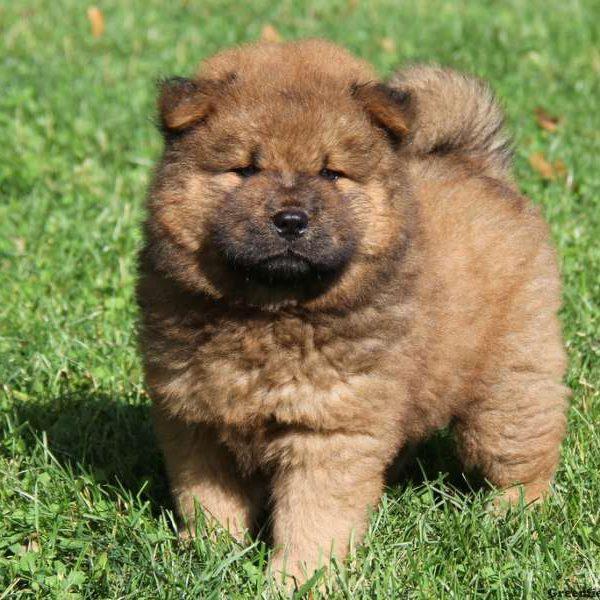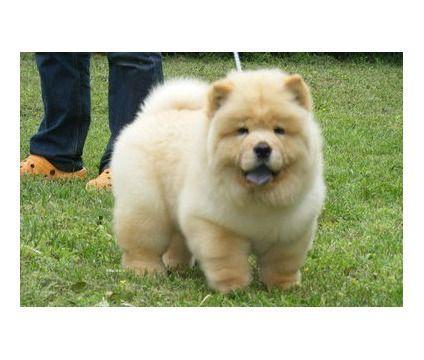The first image is the image on the left, the second image is the image on the right. For the images shown, is this caption "Each of the images depicts a single chow dog." true? Answer yes or no. Yes. 